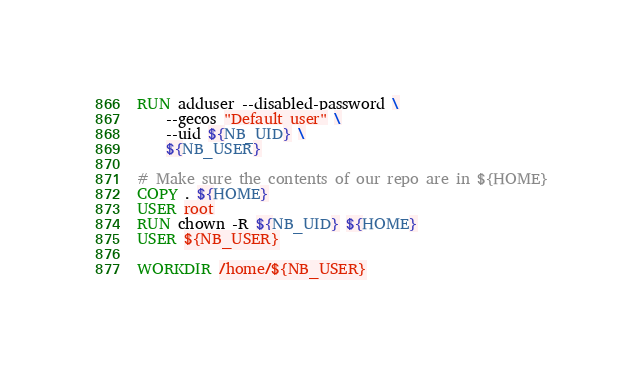<code> <loc_0><loc_0><loc_500><loc_500><_Dockerfile_>
RUN adduser --disabled-password \
    --gecos "Default user" \
    --uid ${NB_UID} \
    ${NB_USER}

# Make sure the contents of our repo are in ${HOME}
COPY . ${HOME}
USER root
RUN chown -R ${NB_UID} ${HOME}
USER ${NB_USER}

WORKDIR /home/${NB_USER}

</code> 